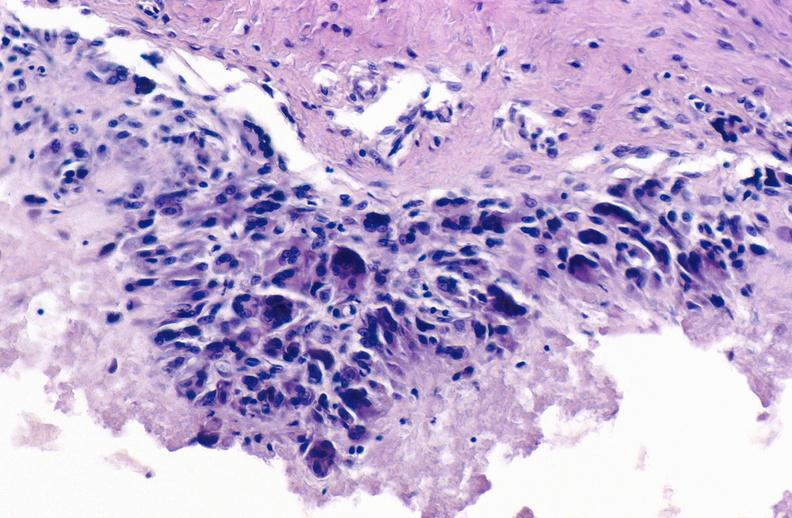does this image show gout?
Answer the question using a single word or phrase. Yes 